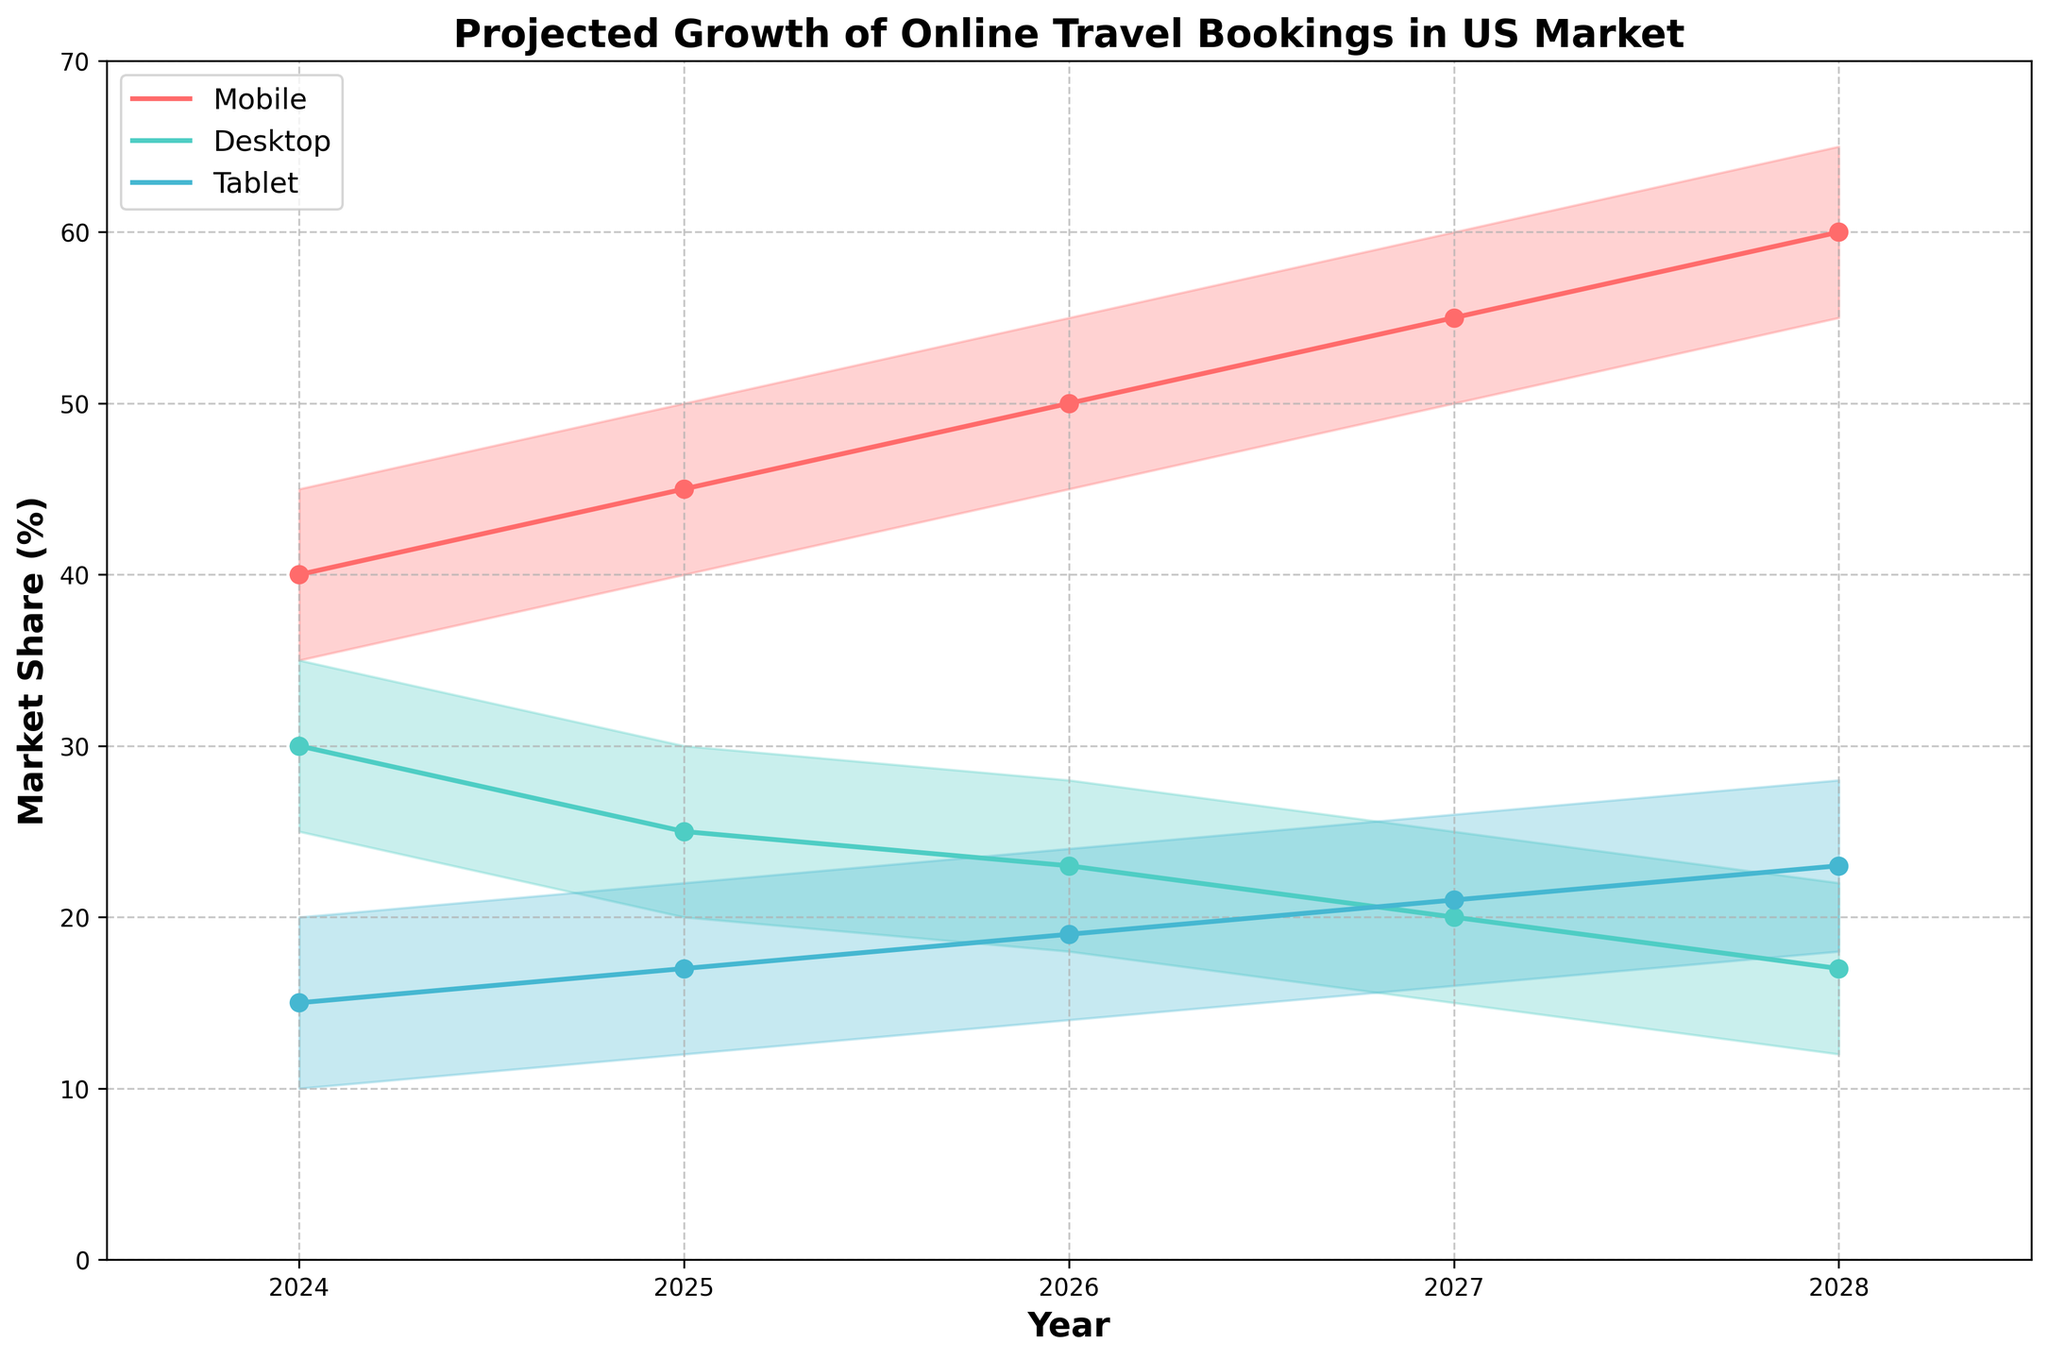What is the title of the chart? The title is displayed at the top of the chart, clearly stating what the figure represents.
Answer: Projected Growth of Online Travel Bookings in US Market Which device type is projected to have the highest mid-range market share in 2026? By looking at the mid-range lines for 2026, we can identify the highest point among the devices.
Answer: Mobile How does the projected high range for mobile device market share in 2028 compare to its high range in 2024? The high range for mobile in 2024 is 45%, and in 2028 it is 65%. By calculating the difference, we can compare.
Answer: 20% increase Which device shows a decreasing mid-range market share projection over the years? By tracking the mid-range lines for each device across the years, the desktop line shows a downward trend.
Answer: Desktop What is the difference between the projected low range market share for tablets in 2025 and 2027? The low range for tablets in 2025 is 12%, and in 2027 it is 16%. The difference is calculated by subtracting the smaller number from the larger number.
Answer: 4% What are the three main colors used in the chart and which device does each color represent? The chart uses different colors to represent each device type. By observing the colors and their corresponding lines, we identify the representations.
Answer: Red for Mobile, Teal for Desktop, Blue for Tablet In which year is the projected mid-range market share for desktops the lowest? By following the mid-range line for desktops, the lowest point occurs in 2028.
Answer: 2028 What is the range of projected market share for tablets in 2027? The projected low and high range for tablets in 2027 are 16% and 26%, respectively. The range is the difference between these values.
Answer: 10% How does the projected mid-range market share for mobile devices change from 2024 to 2028? The mid-range market share for mobile in 2024 is 40%, and in 2028 it is 60%. By subtracting the earlier value from the later one, we see the change.
Answer: 20% increase Which device type shows the most stable projections across all years in terms of market share range? By observing the width of the fan projections for all devices over the years, the tablet projections are the most consistent in range.
Answer: Tablet 